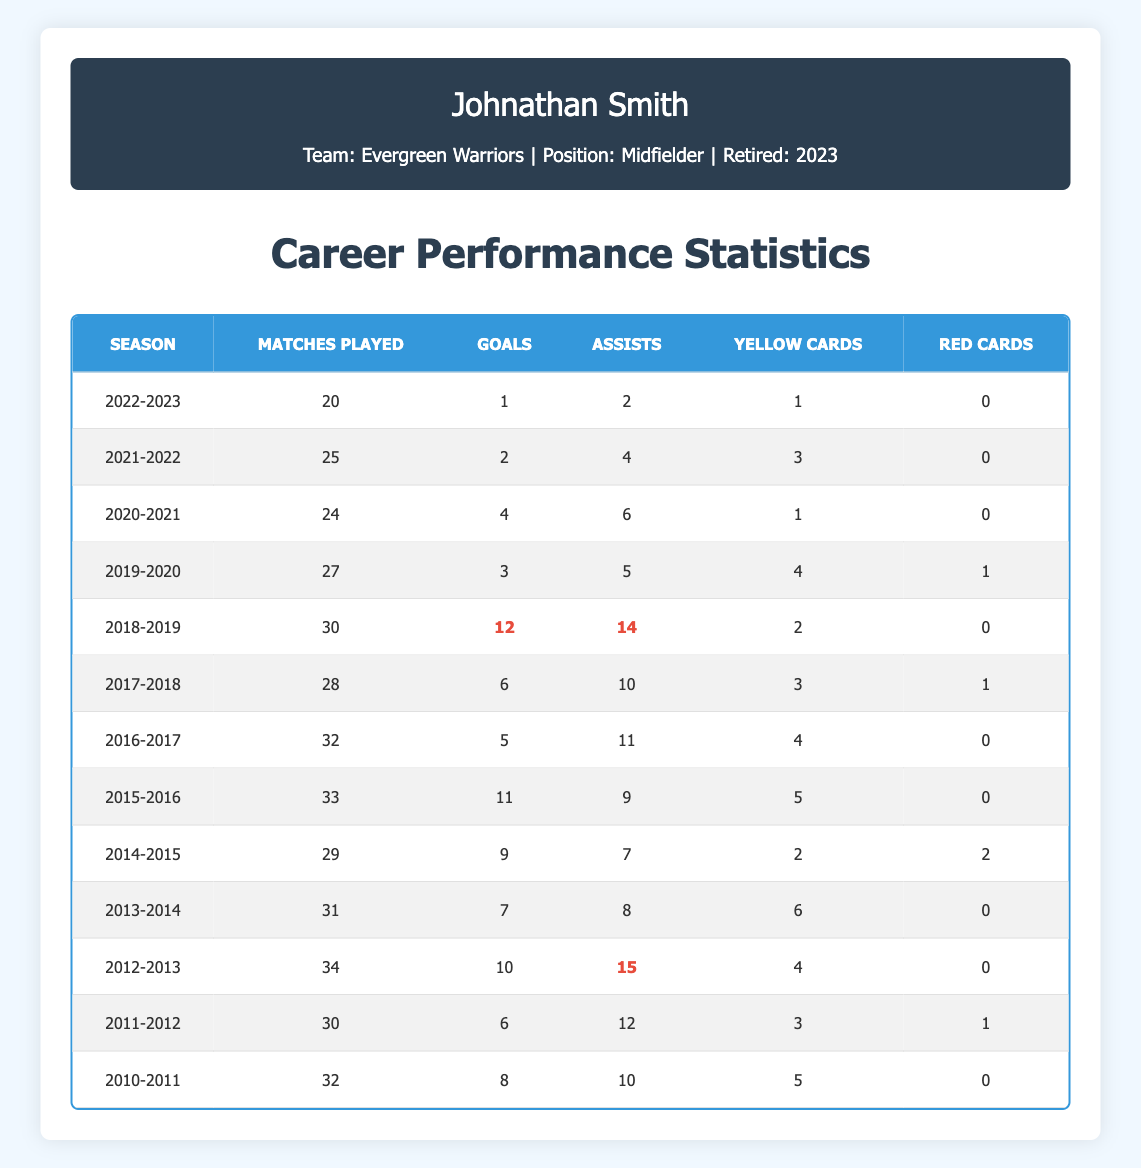What was Johnathan Smith's highest goal-scoring season? The table shows the number of goals scored each season. The highest value is 12 goals in the 2018-2019 season.
Answer: 2018-2019 How many assists did Johnathan Smith make in the 2015-2016 season? The table lists 9 assists for the 2015-2016 season.
Answer: 9 What is the total number of matches Johnathan Smith played in his career? Summing the number of matches played across all seasons gives us 32 + 30 + 34 + 31 + 29 + 33 + 32 + 28 + 30 + 27 + 24 + 25 + 20 =  392.
Answer: 392 Did Johnathan Smith receive more yellow cards than red cards over his career? Counting yellow cards (20) and red cards (6), he received more yellow cards than red cards.
Answer: Yes What was the average number of assists over his career? The sum of assists is 10 + 12 + 15 + 8 + 7 + 9 + 11 + 10 + 14 + 5 + 6 + 4 + 2 =  12. The number of seasons is 13. Therefore, the average assists = 12 / 13 ≈ 9.23.
Answer: Approximately 9.23 In which season did he have the least number of matches played? Looking through the table, the 2022-2023 season has the least matches played, which is 20.
Answer: 2022-2023 How many seasons did Johnathan Smith play where he scored 10 or more goals? The seasons where he scored 10 or more goals are 2012-2013 (10 goals), 2015-2016 (11 goals), 2018-2019 (12 goals), and 2014-2015 (9 goals). Thus, there are three seasons.
Answer: 3 What percentage of Johnathan Smith’s total matches were played in his final season? In the final season (2022-2023), he played 20 matches. The total is 392. The percentage = (20/392) * 100 ≈ 5.10%.
Answer: Approximately 5.10% How many goals did he score in the last three seasons combined? Summing the goals from the last three seasons (2020-2021: 4, 2021-2022: 2, 2022-2023: 1) gives 4 + 2 + 1 = 7 goals.
Answer: 7 Was there any season where Johnathan Smith received a red card? Checking the table shows that he received red cards in 2011-2012 (1) and 2014-2015 (2); therefore, he did.
Answer: Yes 